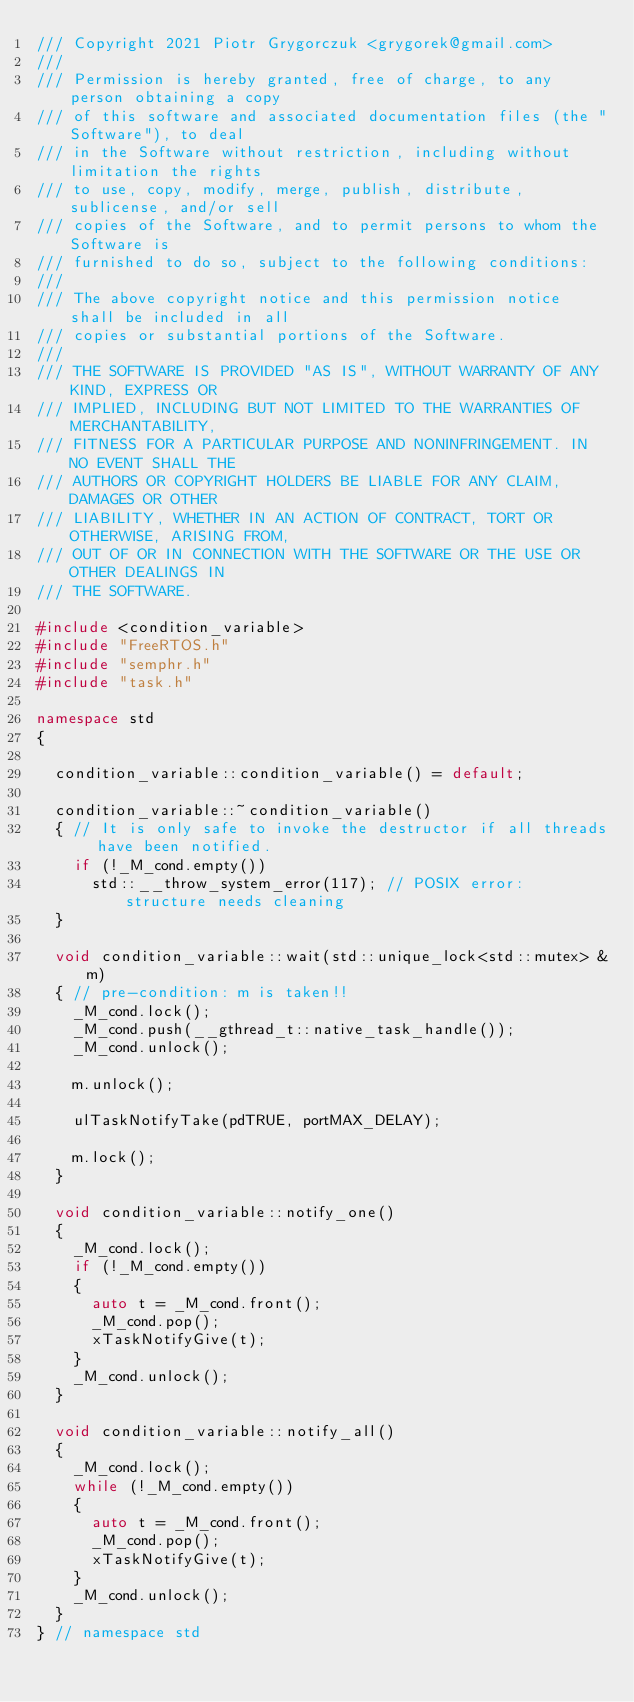Convert code to text. <code><loc_0><loc_0><loc_500><loc_500><_C++_>/// Copyright 2021 Piotr Grygorczuk <grygorek@gmail.com>
///
/// Permission is hereby granted, free of charge, to any person obtaining a copy
/// of this software and associated documentation files (the "Software"), to deal
/// in the Software without restriction, including without limitation the rights
/// to use, copy, modify, merge, publish, distribute, sublicense, and/or sell
/// copies of the Software, and to permit persons to whom the Software is
/// furnished to do so, subject to the following conditions:
///
/// The above copyright notice and this permission notice shall be included in all
/// copies or substantial portions of the Software.
///
/// THE SOFTWARE IS PROVIDED "AS IS", WITHOUT WARRANTY OF ANY KIND, EXPRESS OR
/// IMPLIED, INCLUDING BUT NOT LIMITED TO THE WARRANTIES OF MERCHANTABILITY,
/// FITNESS FOR A PARTICULAR PURPOSE AND NONINFRINGEMENT. IN NO EVENT SHALL THE
/// AUTHORS OR COPYRIGHT HOLDERS BE LIABLE FOR ANY CLAIM, DAMAGES OR OTHER
/// LIABILITY, WHETHER IN AN ACTION OF CONTRACT, TORT OR OTHERWISE, ARISING FROM,
/// OUT OF OR IN CONNECTION WITH THE SOFTWARE OR THE USE OR OTHER DEALINGS IN
/// THE SOFTWARE.

#include <condition_variable>
#include "FreeRTOS.h"
#include "semphr.h"
#include "task.h"

namespace std
{

  condition_variable::condition_variable() = default;

  condition_variable::~condition_variable()
  { // It is only safe to invoke the destructor if all threads have been notified.
    if (!_M_cond.empty())
      std::__throw_system_error(117); // POSIX error: structure needs cleaning
  }

  void condition_variable::wait(std::unique_lock<std::mutex> &m)
  { // pre-condition: m is taken!!
    _M_cond.lock();
    _M_cond.push(__gthread_t::native_task_handle());
    _M_cond.unlock();

    m.unlock();

    ulTaskNotifyTake(pdTRUE, portMAX_DELAY);

    m.lock();
  }

  void condition_variable::notify_one()
  {
    _M_cond.lock();
    if (!_M_cond.empty())
    {
      auto t = _M_cond.front();
      _M_cond.pop();
      xTaskNotifyGive(t);
    }
    _M_cond.unlock();
  }

  void condition_variable::notify_all()
  {
    _M_cond.lock();
    while (!_M_cond.empty())
    {
      auto t = _M_cond.front();
      _M_cond.pop();
      xTaskNotifyGive(t);
    }
    _M_cond.unlock();
  }
} // namespace std</code> 